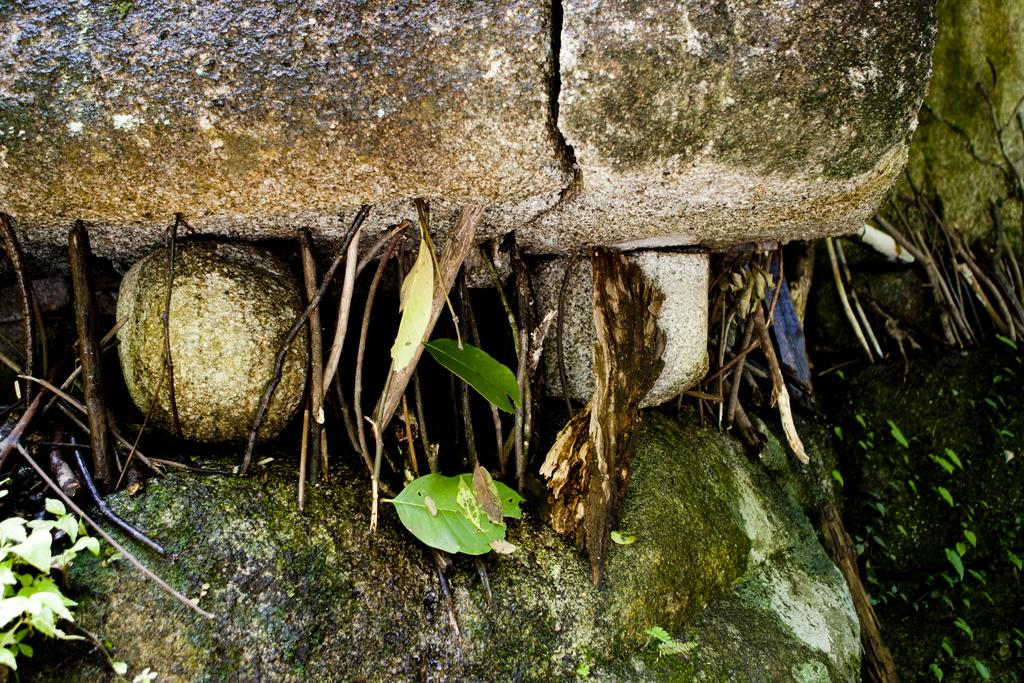What type of natural elements can be seen in the image? There are rocks and leaves in the image. Can you describe the rocks in the image? The rocks in the image are likely solid and may have various shapes and sizes. What can be inferred about the environment from the presence of leaves in the image? The presence of leaves suggests that there might be trees or plants nearby, indicating a natural or outdoor setting. What type of chain can be seen connecting the rocks in the image? There is no chain connecting the rocks in the image; the rocks are likely separate and unconnected. Is there any blood visible on the leaves in the image? There is no blood visible on the leaves in the image; the leaves appear to be undamaged and unstained. 